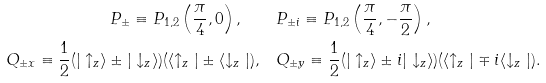Convert formula to latex. <formula><loc_0><loc_0><loc_500><loc_500>P _ { \pm } \equiv P _ { 1 , 2 } \left ( \frac { \pi } { 4 } , 0 \right ) , \quad & P _ { \pm i } \equiv P _ { 1 , 2 } \left ( \frac { \pi } { 4 } , - \frac { \pi } { 2 } \right ) , \\ Q _ { \pm x } \equiv \frac { 1 } { 2 } ( | \uparrow _ { z } \rangle \pm | \downarrow _ { z } \rangle ) ( \langle \uparrow _ { z } | \pm \langle \downarrow _ { z } | ) , \quad & Q _ { \pm y } \equiv \frac { 1 } { 2 } ( | \uparrow _ { z } \rangle \pm i | \downarrow _ { z } \rangle ) ( \langle \uparrow _ { z } | \mp i \langle \downarrow _ { z } | ) .</formula> 